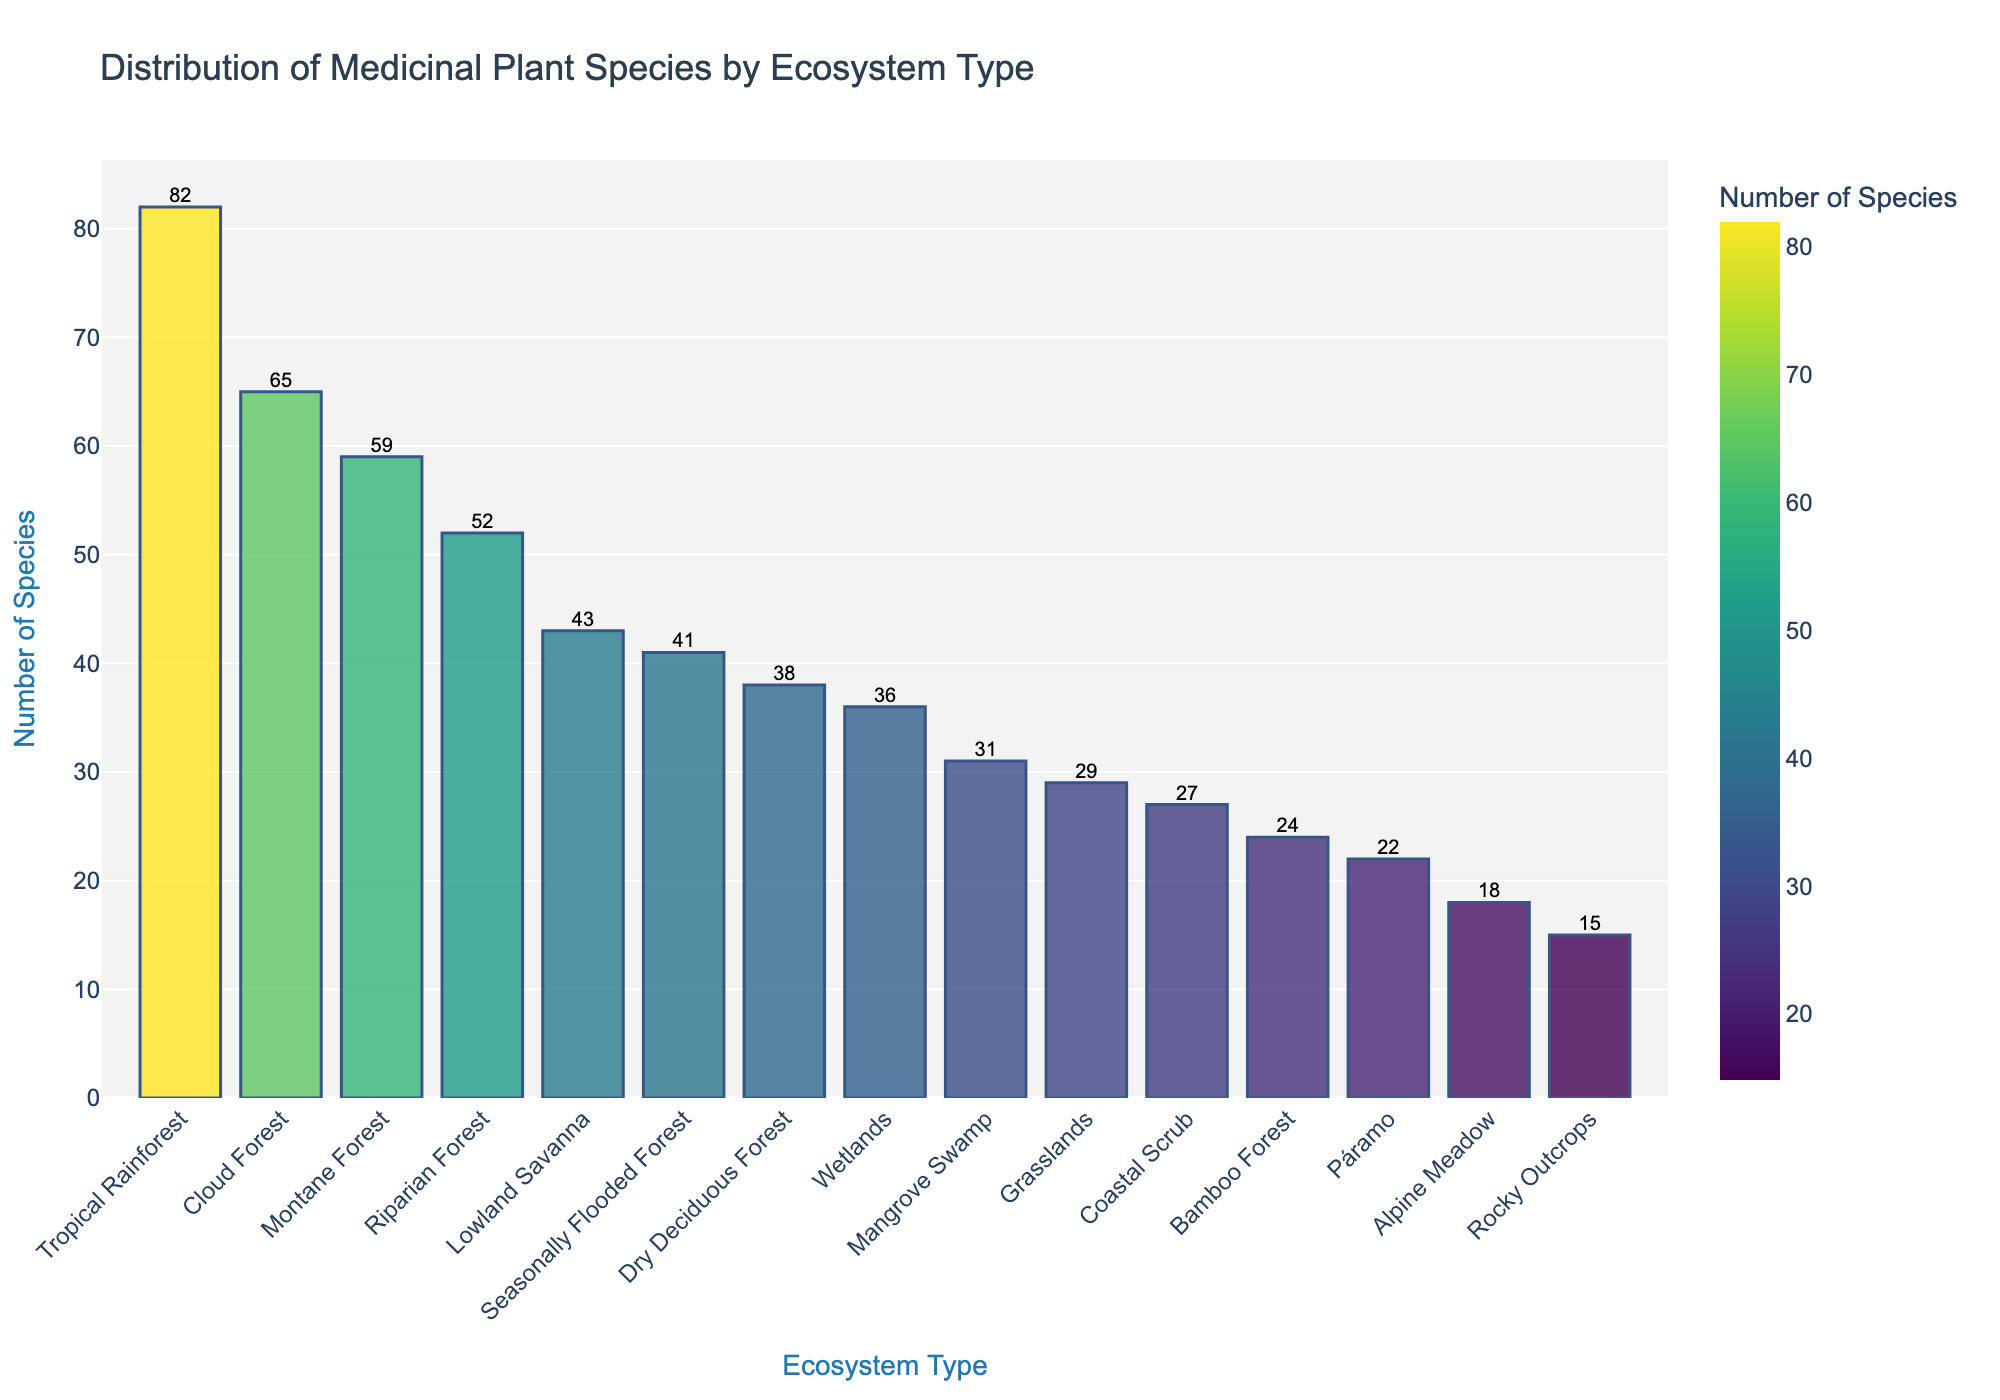Which ecosystem type has the highest number of medicinal plant species? The bar representing the Tropical Rainforest ecosystem is the tallest, indicating that it has the highest number of medicinal plant species.
Answer: Tropical Rainforest How many more medicinal plant species are there in the Tropical Rainforest compared to the Alpine Meadow? The Tropical Rainforest has 82 species, and the Alpine Meadow has 18 species. The difference is 82 - 18 = 64.
Answer: 64 Which ecosystem type has the least number of medicinal plant species? The bar representing the Rocky Outcrops ecosystem is the shortest, indicating that it has the least number of medicinal plant species.
Answer: Rocky Outcrops What is the combined total number of medicinal plant species in the Cloud Forest and the Mangrove Swamp? The Cloud Forest has 65 species, and the Mangrove Swamp has 31 species. The combined total is 65 + 31 = 96.
Answer: 96 Which three ecosystem types have the closest number of medicinal plant species? The Lowland Savanna (43), Seasonally Flooded Forest (41), and Dry Deciduous Forest (38) have the closest numbers of species. The differences between their counts are minimal.
Answer: Lowland Savanna, Seasonally Flooded Forest, Dry Deciduous Forest Is the number of medicinal plant species in the Wetlands greater than that in Grasslands? The Wetlands have 36 species, while the Grasslands have 29 species. Since 36 is greater than 29, the number of species in the Wetlands is greater.
Answer: Yes What’s the average number of medicinal plant species across all ecosystem types? Summing the numbers of species across all ecosystem types gives 582. There are 15 ecosystem types. The average is 582 / 15 ≈ 38.8.
Answer: ~38.8 How many ecosystem types have more than 50 medicinal plant species? Counting the bars that exceed the 50 mark, we find that the Tropical Rainforest, Cloud Forest, Montane Forest, and Riparian Forest have more than 50 species, totaling 4 ecosystem types.
Answer: 4 Which ecosystem has a higher number of medicinal plant species: Coastal Scrub or Bamboo Forest? The Coastal Scrub has 27 species, and the Bamboo Forest has 24 species. Since 27 is greater than 24, Coastal Scrub has more species.
Answer: Coastal Scrub By how much does the number of medicinal plant species in the Dry Deciduous Forest exceed those in the Rocky Outcrops? The Dry Deciduous Forest has 38 species, and the Rocky Outcrops have 15 species. The difference is 38 - 15 = 23.
Answer: 23 